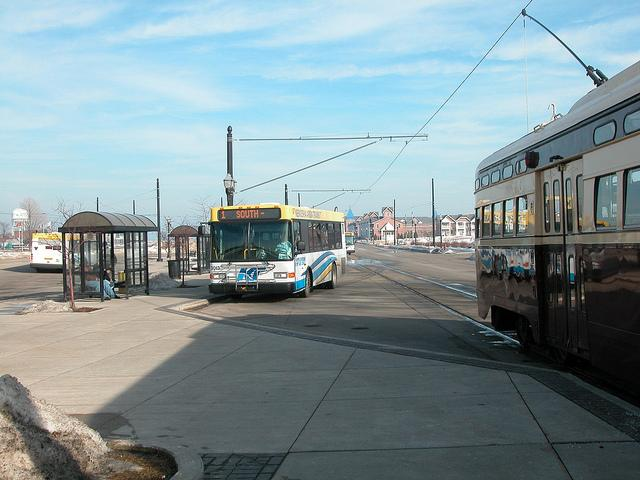What is the overhead wire for? power 